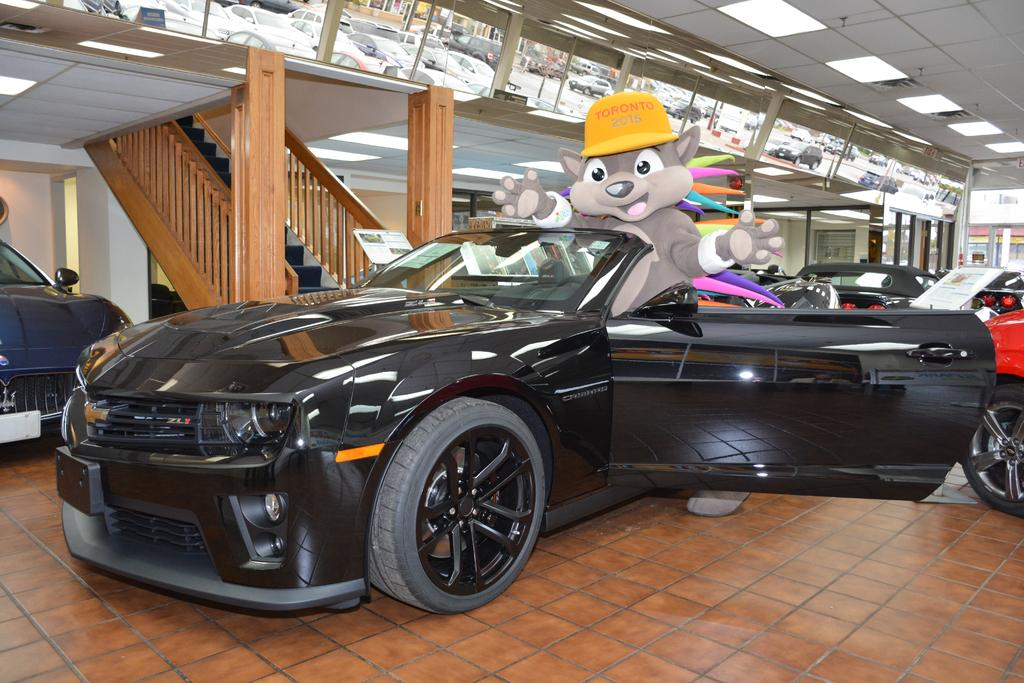What type of vehicles can be seen in the image? There are cars in the image. Where are the cars located? The cars are on a surface in the image. What architectural feature is visible in the image? There are staircases visible in the image. What is attached to the wall in the image? There are boards on the wall in the image. How does the aftermath of the accident affect the gate in the image? There is no mention of an accident or a gate in the image, so it is not possible to answer this question. 